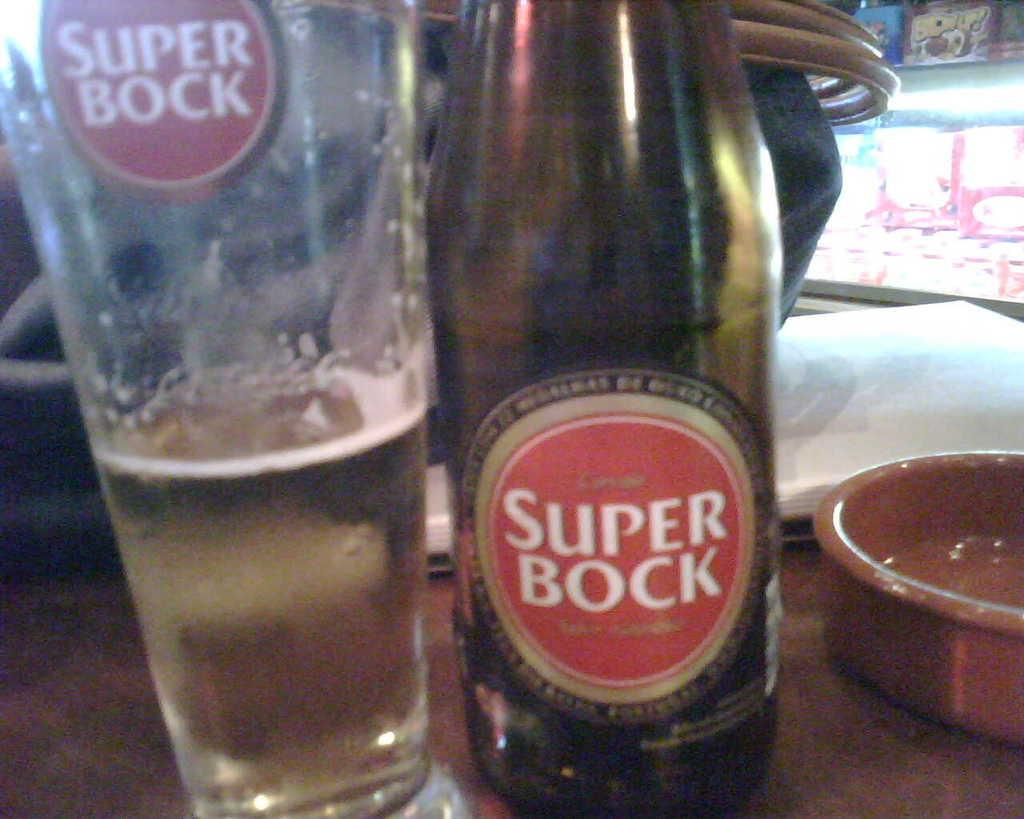Provide a one-sentence caption for the provided image. Beer from a Super Bock bottle is poured into a glass. 